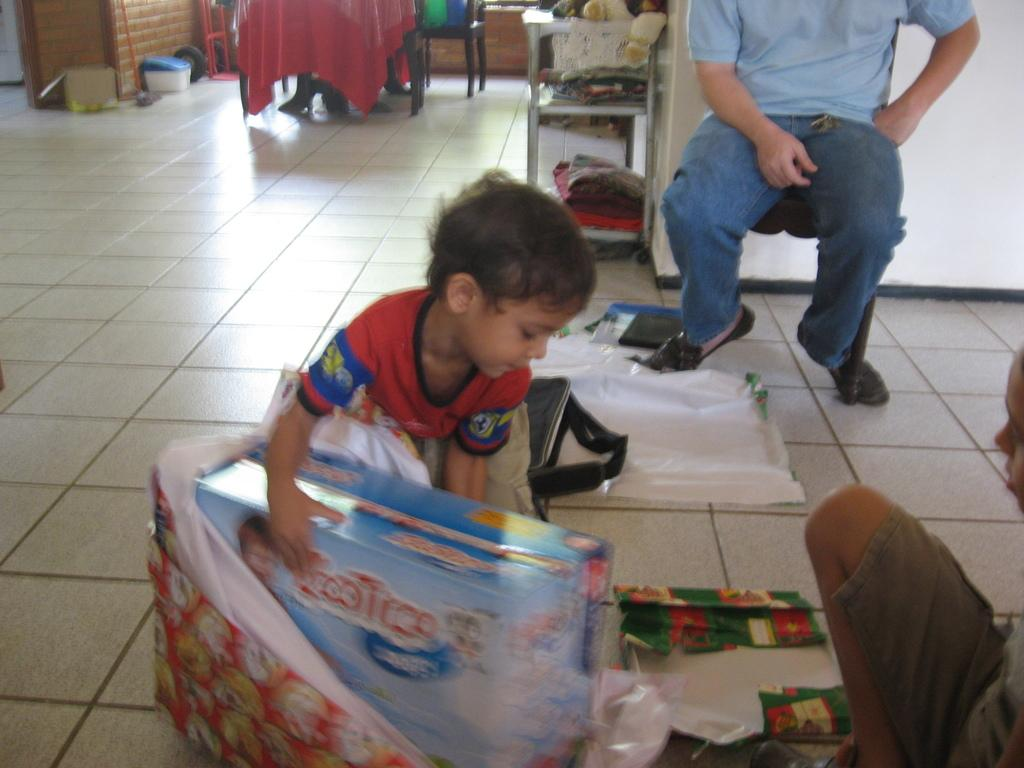What type of flooring is visible at the bottom of the image? There are tiles at the bottom of the image. What is the main subject in the middle of the image? There is a child in the middle of the image. What else can be seen in the middle of the image besides the child? There are toys in the middle of the image. What can be seen in the background of the image? There are other objects visible in the background of the image. What type of chain is wrapped around the earth in the image? There is no chain or earth present in the image; it features tiles, a child, toys, and other objects in the background. 